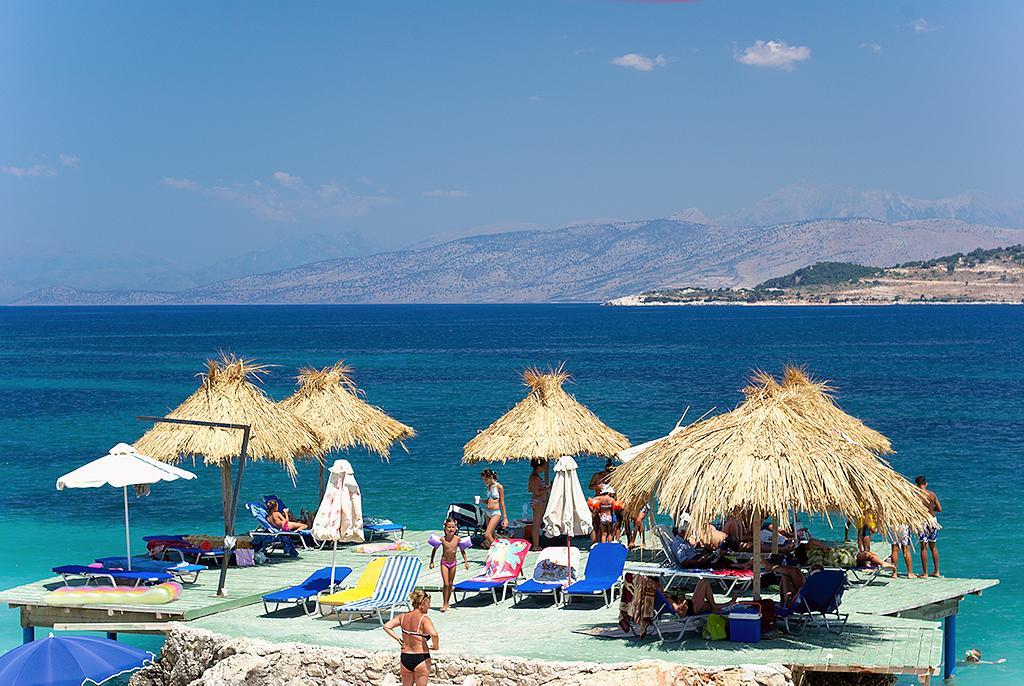Please provide a concise description of this image. There are huts, beds and a chair arranged on the floor on which, there persons. In the background, there is water, there are mountains and there are clouds in the sky. 